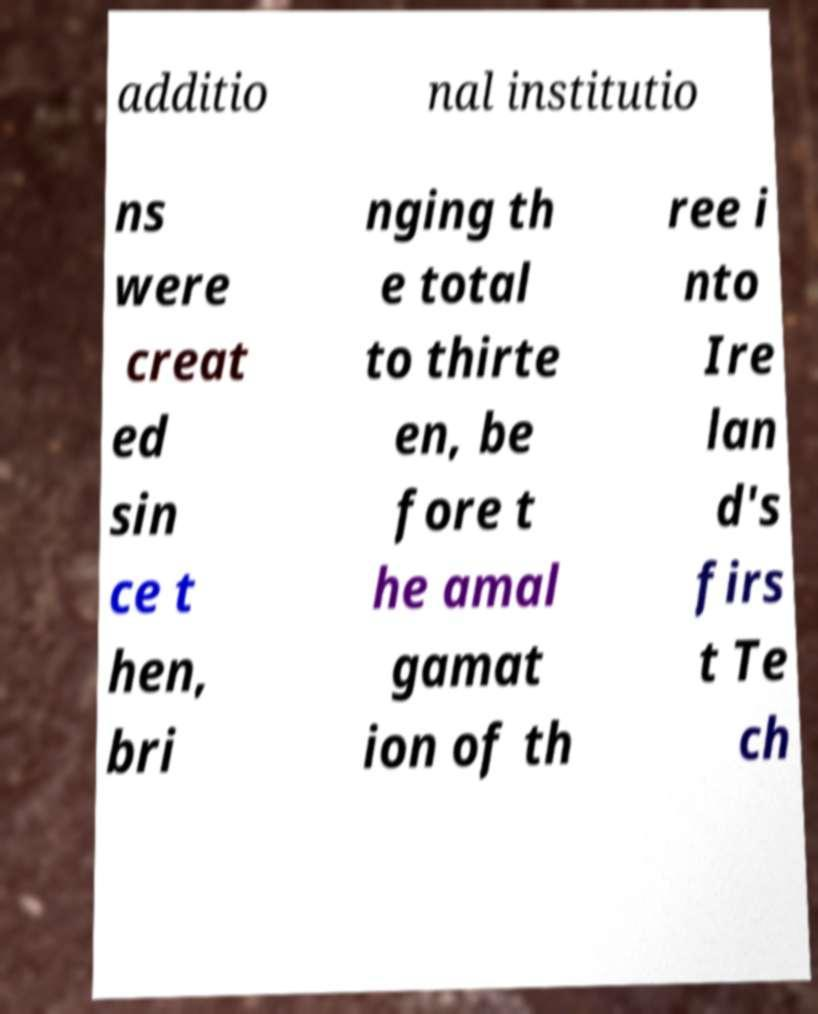Could you extract and type out the text from this image? additio nal institutio ns were creat ed sin ce t hen, bri nging th e total to thirte en, be fore t he amal gamat ion of th ree i nto Ire lan d's firs t Te ch 